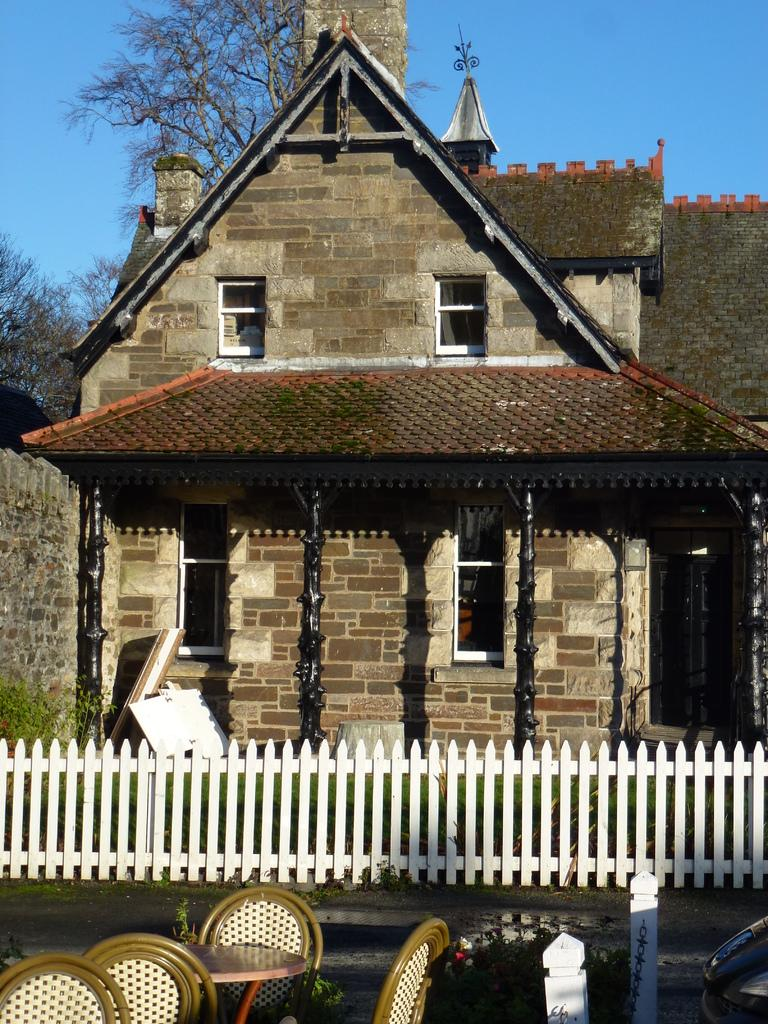What type of structure is visible in the image? There is a building in the image. What can be seen near the building? There is railing, boards, pillars, chairs, a plant, and a table visible in the image. What type of vegetation is present in the image? There are trees in the image. What is visible in the background of the image? The sky is visible in the image. When was the building in the image born? The building in the image is not a living being, so it does not have a birth. 